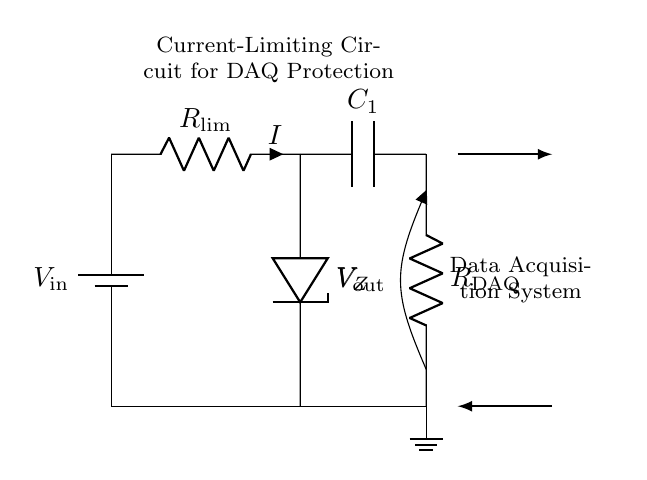What component limits the current in this circuit? The current-limiting resistor, denoted as R_lim, is responsible for limiting the current flowing through the circuit.
Answer: R_lim What type of diode is used in this circuit? The Zener diode, labeled as V_Z, is used for voltage regulation, and it is specifically a diode that allows current to flow in the reverse direction when the voltage exceeds a certain level.
Answer: Zener diode What is the purpose of the capacitor in this circuit? The capacitor, labeled as C_1, is used for smoothing the output voltage, which helps to reduce voltage fluctuations and provides a more stable voltage to the load.
Answer: Smoothing What is the output voltage of the circuit? The output voltage, represented as V_out, is the voltage across the load resistor R_DAQ, indicating the voltage supplied to the data acquisition system.
Answer: V_out Which component represents the data acquisition system? The load resistor, denoted as R_DAQ, represents the data acquisition system in this circuit, as it is where the output voltage is applied for processing data.
Answer: R_DAQ What happens if the current exceeds the limiting value? If the current exceeds the limiting value, the current-limiting resistor R_lim will restrict the current flow, protecting the rest of the circuit from potential damage due to excessive current.
Answer: Current restriction How do the power supply and ground connect in this circuit? The power supply, V_in, connects at the top of the circuit and flows through the components down to the ground connection at the bottom, creating a complete circuit for current flow.
Answer: Series connection 